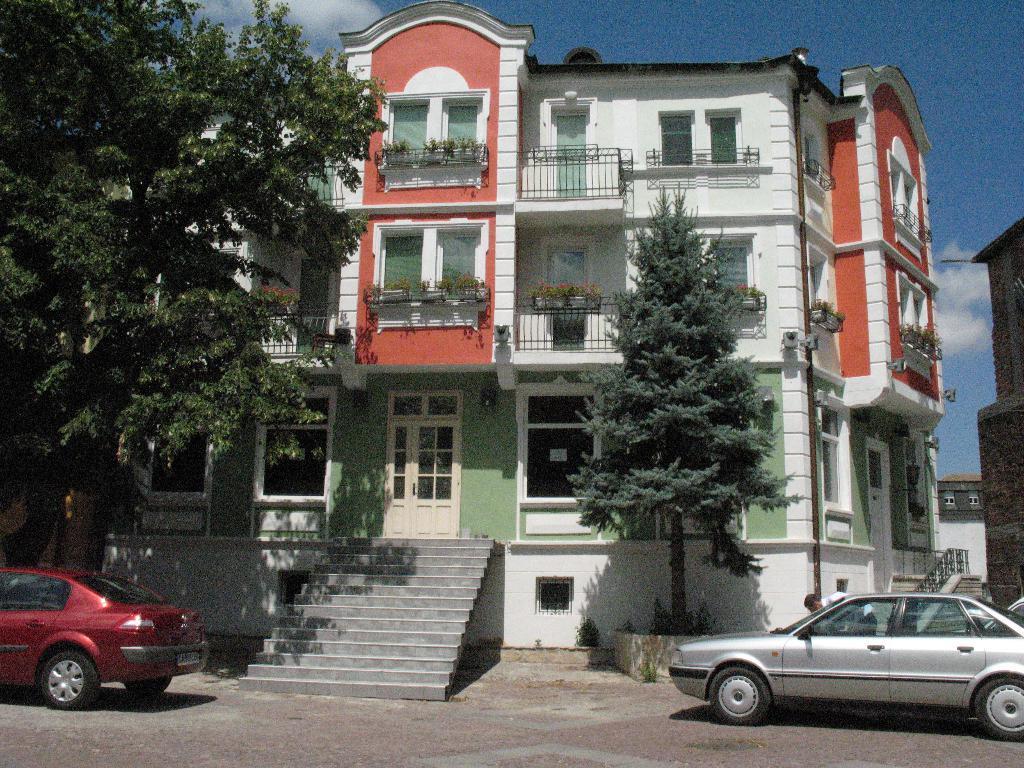Could you give a brief overview of what you see in this image? In this picture there is a building and there is a staircase in front of it and there is a tree and a vehicle on either sides of it and there is another building in the right corner. 